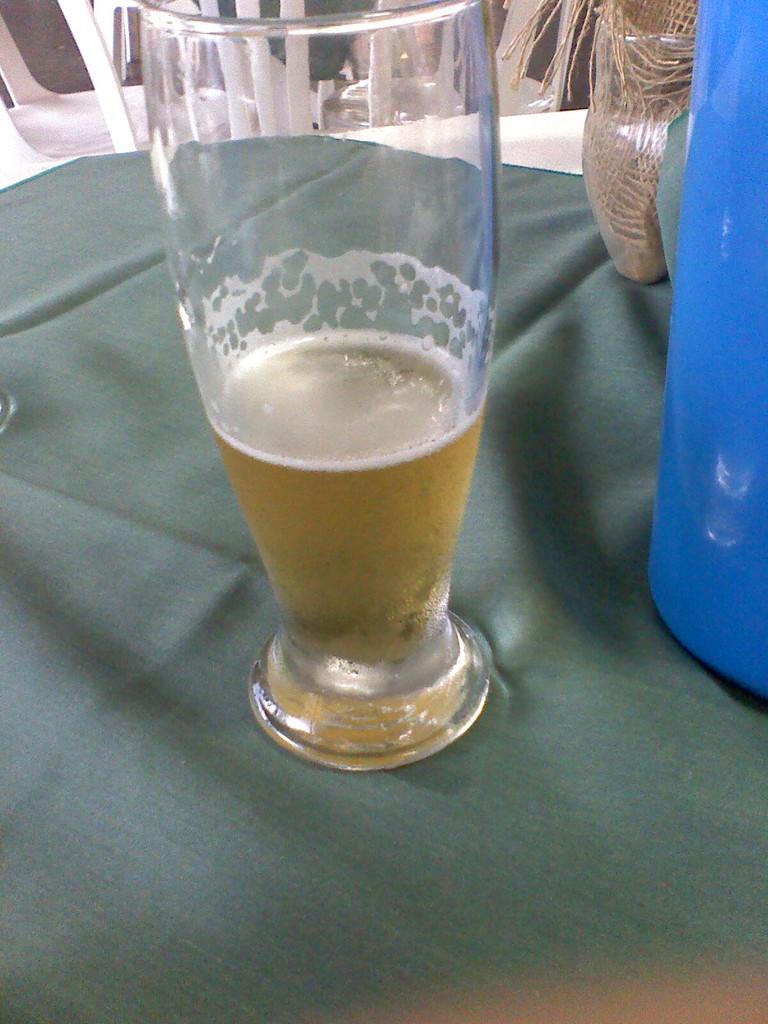Could you give a brief overview of what you see in this image? In this image, we can see a glass with drink and a cloth and some other objects are on the table. In the background, there are chairs. 